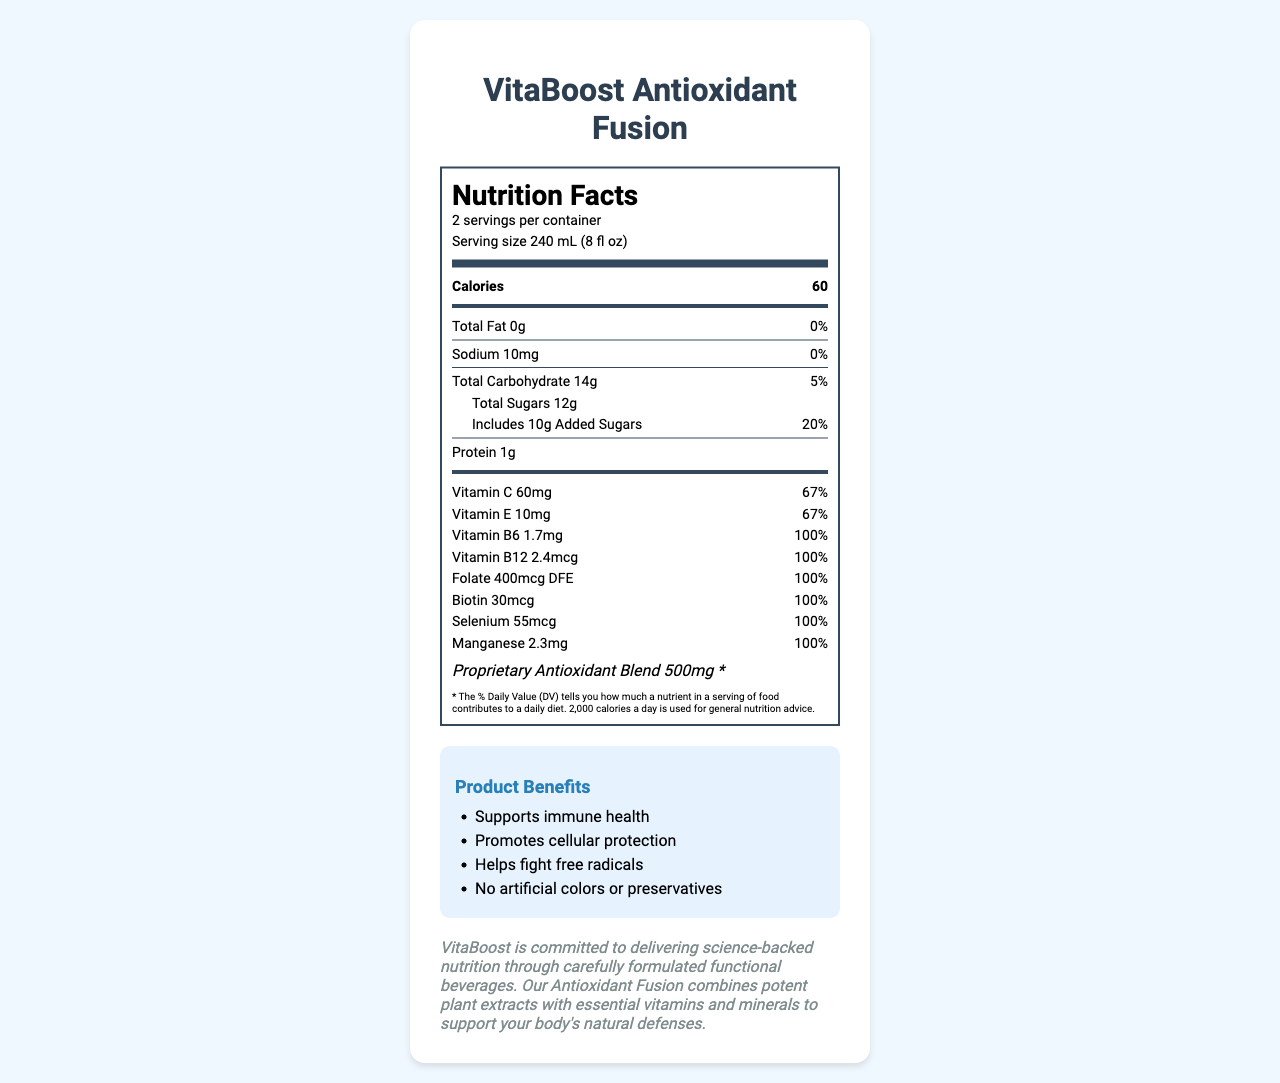What is the serving size of VitaBoost Antioxidant Fusion? The document clearly states that the serving size is 240 mL (8 fl oz).
Answer: 240 mL (8 fl oz) How many calories are there per serving? The document lists the calories as 60 per serving.
Answer: 60 What percentage of the daily value of Vitamin C is provided per serving? The document specifies that each serving contains 60mg of Vitamin C, which is 67% of the daily value.
Answer: 67% How many servings are there per container? The document mentions that there are 2 servings per container.
Answer: 2 List the proprietary antioxidant blend ingredients. The proprietary antioxidant blend is described as containing Green tea extract, Grape seed extract, Pomegranate extract, and Acai berry powder.
Answer: Green tea extract, Grape seed extract, Pomegranate extract, Acai berry powder How many grams of total sugars are there per serving? The document indicates that there are 12 grams of total sugars per serving.
Answer: 12g What percentage of the daily value of added sugars does VitaBoost provide per serving? The document states that there are 10 grams of added sugars, which correspond to 20% of the daily value.
Answer: 20% True or False: VitaBoost Antioxidant Fusion contains artificial preservatives. The document states there are "No artificial colors or preservatives."
Answer: False Which of the following vitamins and minerals are included in VitaBoost Antioxidant Fusion? A. Vitamin D B. Vitamin E C. Zinc D. Magnesium The document lists Vitamin E as part of the ingredients but does not mention Vitamin D, Zinc, or Magnesium.
Answer: B. Vitamin E How much protein does VitaBoost Antioxidant Fusion provide per serving? The document indicates that there is 1 gram of protein per serving.
Answer: 1g What amount of Biotin is there per serving? The document lists 30mcg as the amount of Biotin per serving.
Answer: 30mcg Which of the following benefits are claimed by VitaBoost Antioxidant Fusion? I. Supports immune health II. Promotes bone health III. Helps fight free radicals IV. No artificial colors The document lists "Supports immune health", "Helps fight free radicals", and "No artificial colors or preservatives" as benefits. Promoting bone health is not listed.
Answer: I, III, IV Describe the overall purpose and branding focus of the VitaBoost Antioxidant Fusion beverage. The document outlines the nutritional benefits, the ingredients used, and the brand's commitment to health and environmental sustainability. This includes their use of natural ingredients, science-backed formulations, and eco-friendly packaging.
Answer: The purpose of VitaBoost Antioxidant Fusion is to provide a functional beverage that supports immune health, promotes cellular protection, and helps fight free radicals through added vitamins and a proprietary antioxidant blend. The brand claims to be science-backed with a strong commitment to nutrition and environmental responsibility through recyclable packaging. What is the percentage daily value of sodium per serving? The document notes that each serving contains 10mg of sodium, which is 0% of the daily value.
Answer: 0% What is the daily value percentage contribution of the proprietary antioxidant blend in VitaBoost? The document marks the daily value for the proprietary antioxidant blend as "*", indicating it is not specified.
Answer: * What is the exact weight of the proprietary antioxidant blend per serving? The document specifies that the proprietary antioxidant blend weighs 500mg per serving.
Answer: 500mg Who produces the VitaBoost Antioxidant Fusion beverage? The document does not provide information about the producer or manufacturer of the beverage.
Answer: Cannot be determined Is VitaBoost Antioxidant Fusion suitable for people with soy allergies? The document mentions that the product is produced in a facility that also processes soy and tree nuts, but it does not specify if the product itself contains soy.
Answer: Cannot be determined 